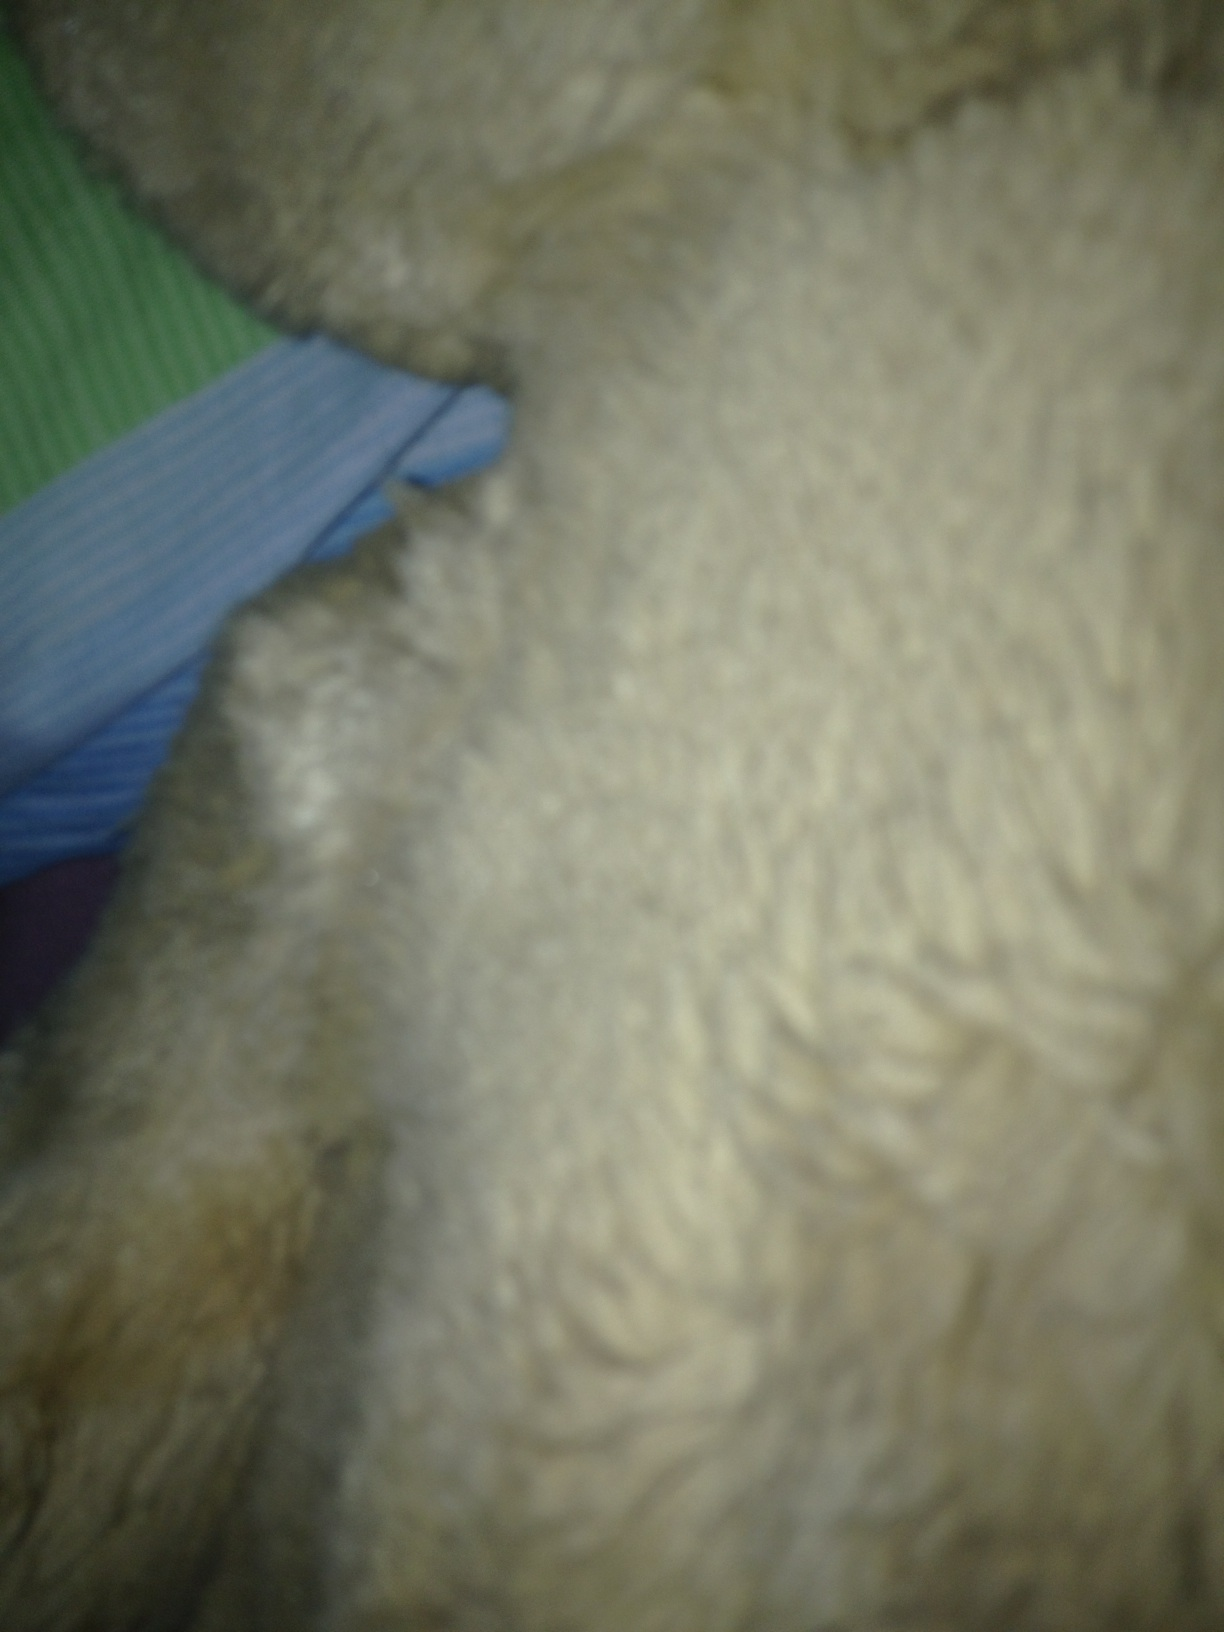How would you describe this texture if it were part of an alien environment? In an alien environment, this texture could belong to a strange and fascinating organism. Perhaps on a distant planet, creatures have evolved with thick, luxurious fur to protect them from extreme temperatures. The soft strands could be equipped with bioluminescent properties, glowing faintly in the dark and creating a mesmerizing light show as they move. The green and blue fabric in the background could represent the unusual foliage of this alien world, with plants that shimmer and change colors to communicate with each other or warn of approaching danger. Describe a realistic scenario with this alien creature. A group of astronauts from Earth has landed on an alien planet for the first time. As they venture out of their spacecraft, they encounter an environment unlike anything they've seen before. Amid the strange, glowing vegetation, they spot a creature with a soft, furry coat that sparkles with bioluminescent light. The creature is shy at first but gradually warms up to the astronauts, showing signs of intelligence and curiosity. The astronauts document their interactions and learn about the creature's unique adaptations to its environment. Their findings provide valuable insights into the biodiversity of the planet and its potential for future exploration. Create a short scenario featuring the alien creature. During a night-time exploration, the astronauts see a gentle glow moving through the dense foliage. They follow the light to discover a small, furry alien creature. Its fur emits a soft, calming glow, and it curiously sniffs at the astronauts' hands. They name it 'Lumos' and marvel at its gentle demeanor and bioluminescent fur, taking this brief interaction as a positive sign of the new planet's lifeforms. 